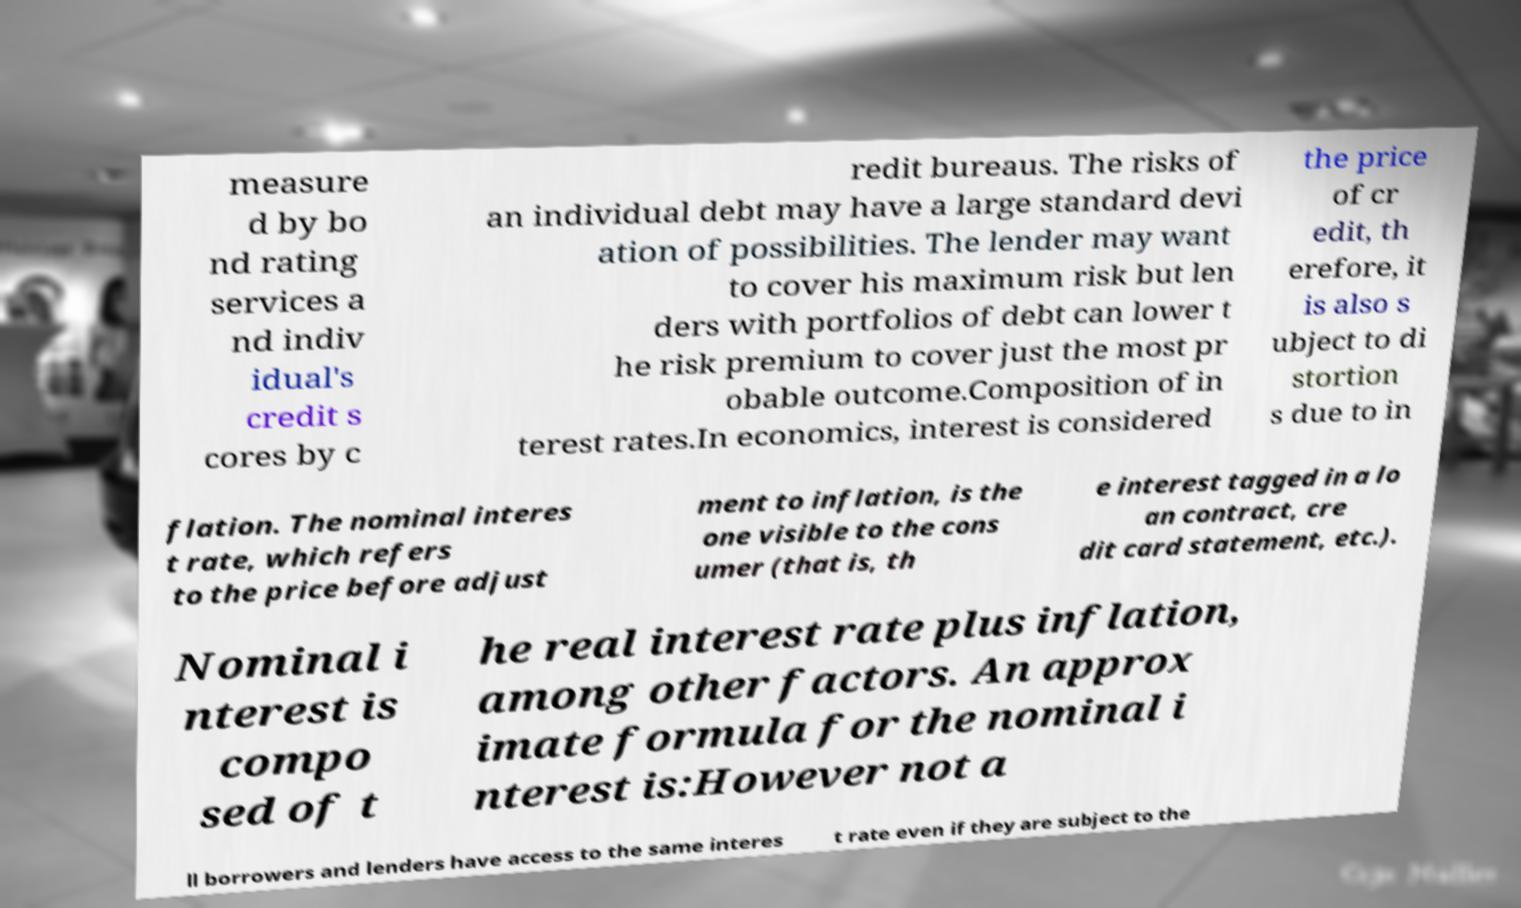What messages or text are displayed in this image? I need them in a readable, typed format. measure d by bo nd rating services a nd indiv idual's credit s cores by c redit bureaus. The risks of an individual debt may have a large standard devi ation of possibilities. The lender may want to cover his maximum risk but len ders with portfolios of debt can lower t he risk premium to cover just the most pr obable outcome.Composition of in terest rates.In economics, interest is considered the price of cr edit, th erefore, it is also s ubject to di stortion s due to in flation. The nominal interes t rate, which refers to the price before adjust ment to inflation, is the one visible to the cons umer (that is, th e interest tagged in a lo an contract, cre dit card statement, etc.). Nominal i nterest is compo sed of t he real interest rate plus inflation, among other factors. An approx imate formula for the nominal i nterest is:However not a ll borrowers and lenders have access to the same interes t rate even if they are subject to the 